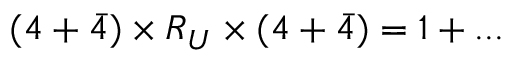<formula> <loc_0><loc_0><loc_500><loc_500>\begin{array} { r } { ( 4 + \bar { 4 } ) \times R _ { U } \times ( 4 + \bar { 4 } ) = 1 + \dots } \end{array}</formula> 